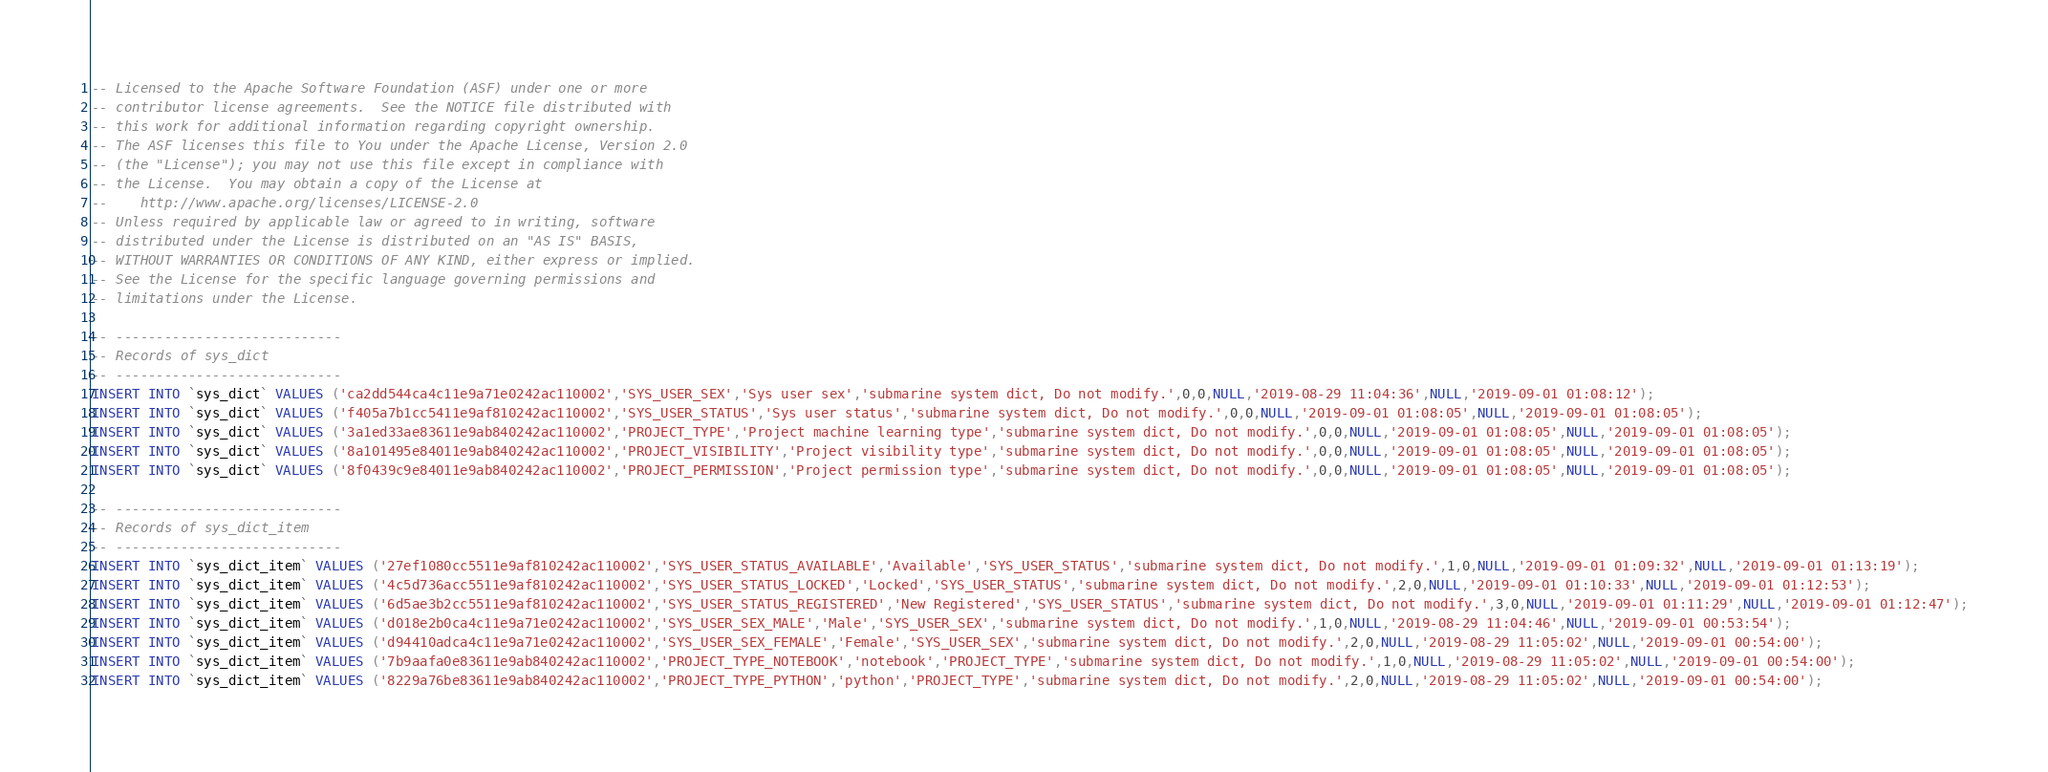<code> <loc_0><loc_0><loc_500><loc_500><_SQL_>-- Licensed to the Apache Software Foundation (ASF) under one or more
-- contributor license agreements.  See the NOTICE file distributed with
-- this work for additional information regarding copyright ownership.
-- The ASF licenses this file to You under the Apache License, Version 2.0
-- (the "License"); you may not use this file except in compliance with
-- the License.  You may obtain a copy of the License at
--    http://www.apache.org/licenses/LICENSE-2.0
-- Unless required by applicable law or agreed to in writing, software
-- distributed under the License is distributed on an "AS IS" BASIS,
-- WITHOUT WARRANTIES OR CONDITIONS OF ANY KIND, either express or implied.
-- See the License for the specific language governing permissions and
-- limitations under the License.

-- ----------------------------
-- Records of sys_dict
-- ----------------------------
INSERT INTO `sys_dict` VALUES ('ca2dd544ca4c11e9a71e0242ac110002','SYS_USER_SEX','Sys user sex','submarine system dict, Do not modify.',0,0,NULL,'2019-08-29 11:04:36',NULL,'2019-09-01 01:08:12');
INSERT INTO `sys_dict` VALUES ('f405a7b1cc5411e9af810242ac110002','SYS_USER_STATUS','Sys user status','submarine system dict, Do not modify.',0,0,NULL,'2019-09-01 01:08:05',NULL,'2019-09-01 01:08:05');
INSERT INTO `sys_dict` VALUES ('3a1ed33ae83611e9ab840242ac110002','PROJECT_TYPE','Project machine learning type','submarine system dict, Do not modify.',0,0,NULL,'2019-09-01 01:08:05',NULL,'2019-09-01 01:08:05');
INSERT INTO `sys_dict` VALUES ('8a101495e84011e9ab840242ac110002','PROJECT_VISIBILITY','Project visibility type','submarine system dict, Do not modify.',0,0,NULL,'2019-09-01 01:08:05',NULL,'2019-09-01 01:08:05');
INSERT INTO `sys_dict` VALUES ('8f0439c9e84011e9ab840242ac110002','PROJECT_PERMISSION','Project permission type','submarine system dict, Do not modify.',0,0,NULL,'2019-09-01 01:08:05',NULL,'2019-09-01 01:08:05');

-- ----------------------------
-- Records of sys_dict_item
-- ----------------------------
INSERT INTO `sys_dict_item` VALUES ('27ef1080cc5511e9af810242ac110002','SYS_USER_STATUS_AVAILABLE','Available','SYS_USER_STATUS','submarine system dict, Do not modify.',1,0,NULL,'2019-09-01 01:09:32',NULL,'2019-09-01 01:13:19');
INSERT INTO `sys_dict_item` VALUES ('4c5d736acc5511e9af810242ac110002','SYS_USER_STATUS_LOCKED','Locked','SYS_USER_STATUS','submarine system dict, Do not modify.',2,0,NULL,'2019-09-01 01:10:33',NULL,'2019-09-01 01:12:53');
INSERT INTO `sys_dict_item` VALUES ('6d5ae3b2cc5511e9af810242ac110002','SYS_USER_STATUS_REGISTERED','New Registered','SYS_USER_STATUS','submarine system dict, Do not modify.',3,0,NULL,'2019-09-01 01:11:29',NULL,'2019-09-01 01:12:47');
INSERT INTO `sys_dict_item` VALUES ('d018e2b0ca4c11e9a71e0242ac110002','SYS_USER_SEX_MALE','Male','SYS_USER_SEX','submarine system dict, Do not modify.',1,0,NULL,'2019-08-29 11:04:46',NULL,'2019-09-01 00:53:54');
INSERT INTO `sys_dict_item` VALUES ('d94410adca4c11e9a71e0242ac110002','SYS_USER_SEX_FEMALE','Female','SYS_USER_SEX','submarine system dict, Do not modify.',2,0,NULL,'2019-08-29 11:05:02',NULL,'2019-09-01 00:54:00');
INSERT INTO `sys_dict_item` VALUES ('7b9aafa0e83611e9ab840242ac110002','PROJECT_TYPE_NOTEBOOK','notebook','PROJECT_TYPE','submarine system dict, Do not modify.',1,0,NULL,'2019-08-29 11:05:02',NULL,'2019-09-01 00:54:00');
INSERT INTO `sys_dict_item` VALUES ('8229a76be83611e9ab840242ac110002','PROJECT_TYPE_PYTHON','python','PROJECT_TYPE','submarine system dict, Do not modify.',2,0,NULL,'2019-08-29 11:05:02',NULL,'2019-09-01 00:54:00');</code> 